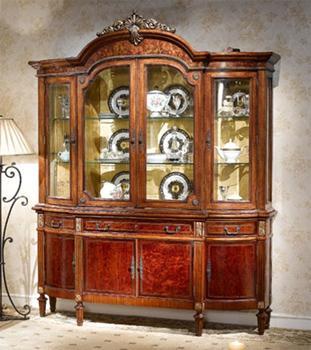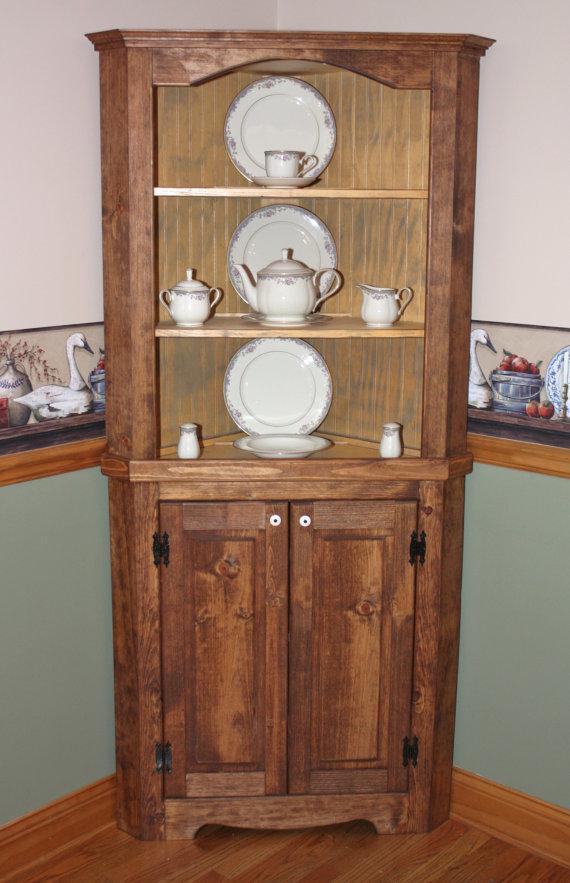The first image is the image on the left, the second image is the image on the right. Considering the images on both sides, is "There are four plates on each shelf in the image on the left" valid? Answer yes or no. No. The first image is the image on the left, the second image is the image on the right. Examine the images to the left and right. Is the description "There is one hutch with doors open." accurate? Answer yes or no. No. 